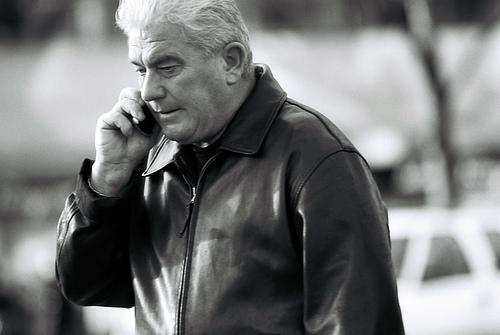Is the man old?
Concise answer only. Yes. What is the man talking on?
Keep it brief. Cell phone. Is the man wearing a leather jacket?
Quick response, please. Yes. 